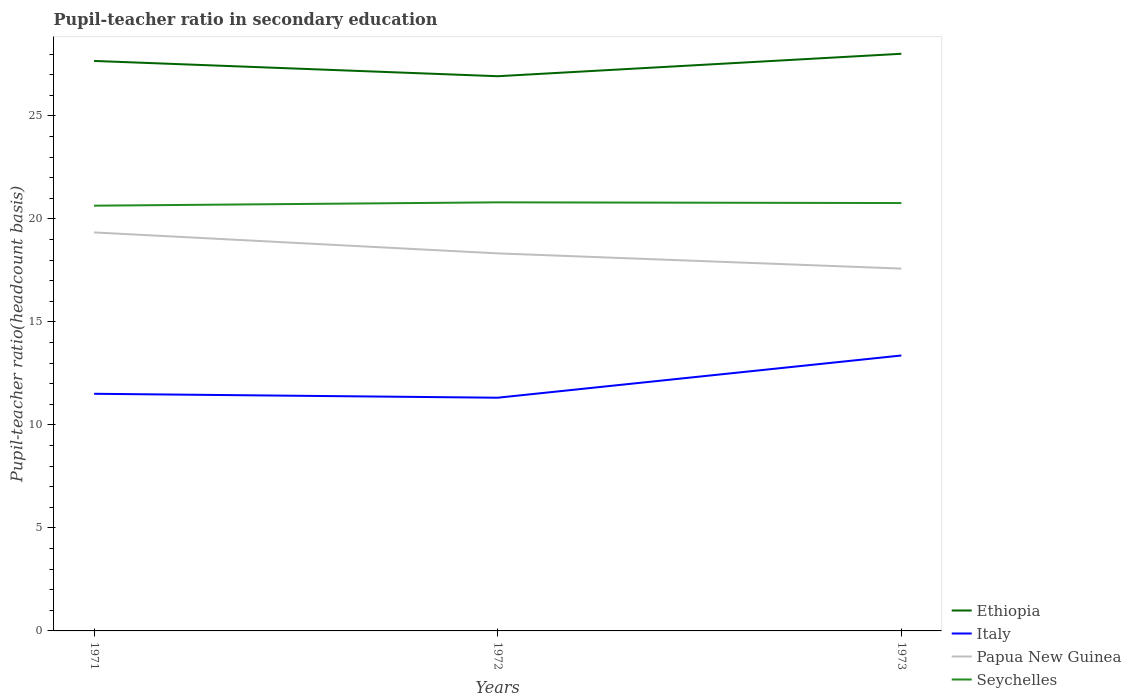Is the number of lines equal to the number of legend labels?
Keep it short and to the point. Yes. Across all years, what is the maximum pupil-teacher ratio in secondary education in Papua New Guinea?
Keep it short and to the point. 17.59. What is the total pupil-teacher ratio in secondary education in Ethiopia in the graph?
Offer a terse response. 0.74. What is the difference between the highest and the second highest pupil-teacher ratio in secondary education in Ethiopia?
Give a very brief answer. 1.09. What is the difference between the highest and the lowest pupil-teacher ratio in secondary education in Italy?
Provide a short and direct response. 1. How many years are there in the graph?
Your response must be concise. 3. How many legend labels are there?
Offer a terse response. 4. How are the legend labels stacked?
Provide a short and direct response. Vertical. What is the title of the graph?
Offer a very short reply. Pupil-teacher ratio in secondary education. Does "Least developed countries" appear as one of the legend labels in the graph?
Keep it short and to the point. No. What is the label or title of the X-axis?
Provide a succinct answer. Years. What is the label or title of the Y-axis?
Give a very brief answer. Pupil-teacher ratio(headcount basis). What is the Pupil-teacher ratio(headcount basis) in Ethiopia in 1971?
Make the answer very short. 27.67. What is the Pupil-teacher ratio(headcount basis) of Italy in 1971?
Make the answer very short. 11.51. What is the Pupil-teacher ratio(headcount basis) of Papua New Guinea in 1971?
Make the answer very short. 19.35. What is the Pupil-teacher ratio(headcount basis) in Seychelles in 1971?
Provide a succinct answer. 20.65. What is the Pupil-teacher ratio(headcount basis) in Ethiopia in 1972?
Provide a short and direct response. 26.93. What is the Pupil-teacher ratio(headcount basis) of Italy in 1972?
Keep it short and to the point. 11.32. What is the Pupil-teacher ratio(headcount basis) of Papua New Guinea in 1972?
Provide a succinct answer. 18.33. What is the Pupil-teacher ratio(headcount basis) in Seychelles in 1972?
Ensure brevity in your answer.  20.81. What is the Pupil-teacher ratio(headcount basis) in Ethiopia in 1973?
Provide a short and direct response. 28.02. What is the Pupil-teacher ratio(headcount basis) in Italy in 1973?
Offer a very short reply. 13.37. What is the Pupil-teacher ratio(headcount basis) of Papua New Guinea in 1973?
Provide a short and direct response. 17.59. What is the Pupil-teacher ratio(headcount basis) of Seychelles in 1973?
Make the answer very short. 20.77. Across all years, what is the maximum Pupil-teacher ratio(headcount basis) of Ethiopia?
Your answer should be very brief. 28.02. Across all years, what is the maximum Pupil-teacher ratio(headcount basis) in Italy?
Keep it short and to the point. 13.37. Across all years, what is the maximum Pupil-teacher ratio(headcount basis) of Papua New Guinea?
Offer a very short reply. 19.35. Across all years, what is the maximum Pupil-teacher ratio(headcount basis) in Seychelles?
Your answer should be compact. 20.81. Across all years, what is the minimum Pupil-teacher ratio(headcount basis) of Ethiopia?
Give a very brief answer. 26.93. Across all years, what is the minimum Pupil-teacher ratio(headcount basis) in Italy?
Make the answer very short. 11.32. Across all years, what is the minimum Pupil-teacher ratio(headcount basis) in Papua New Guinea?
Your answer should be very brief. 17.59. Across all years, what is the minimum Pupil-teacher ratio(headcount basis) of Seychelles?
Give a very brief answer. 20.65. What is the total Pupil-teacher ratio(headcount basis) of Ethiopia in the graph?
Provide a short and direct response. 82.62. What is the total Pupil-teacher ratio(headcount basis) of Italy in the graph?
Make the answer very short. 36.21. What is the total Pupil-teacher ratio(headcount basis) in Papua New Guinea in the graph?
Provide a succinct answer. 55.27. What is the total Pupil-teacher ratio(headcount basis) of Seychelles in the graph?
Provide a succinct answer. 62.23. What is the difference between the Pupil-teacher ratio(headcount basis) of Ethiopia in 1971 and that in 1972?
Offer a very short reply. 0.74. What is the difference between the Pupil-teacher ratio(headcount basis) in Italy in 1971 and that in 1972?
Provide a succinct answer. 0.19. What is the difference between the Pupil-teacher ratio(headcount basis) of Papua New Guinea in 1971 and that in 1972?
Keep it short and to the point. 1.02. What is the difference between the Pupil-teacher ratio(headcount basis) in Seychelles in 1971 and that in 1972?
Offer a terse response. -0.16. What is the difference between the Pupil-teacher ratio(headcount basis) of Ethiopia in 1971 and that in 1973?
Make the answer very short. -0.35. What is the difference between the Pupil-teacher ratio(headcount basis) in Italy in 1971 and that in 1973?
Your answer should be compact. -1.86. What is the difference between the Pupil-teacher ratio(headcount basis) in Papua New Guinea in 1971 and that in 1973?
Your answer should be very brief. 1.76. What is the difference between the Pupil-teacher ratio(headcount basis) in Seychelles in 1971 and that in 1973?
Offer a terse response. -0.13. What is the difference between the Pupil-teacher ratio(headcount basis) in Ethiopia in 1972 and that in 1973?
Your response must be concise. -1.09. What is the difference between the Pupil-teacher ratio(headcount basis) of Italy in 1972 and that in 1973?
Your response must be concise. -2.05. What is the difference between the Pupil-teacher ratio(headcount basis) of Papua New Guinea in 1972 and that in 1973?
Provide a short and direct response. 0.74. What is the difference between the Pupil-teacher ratio(headcount basis) of Seychelles in 1972 and that in 1973?
Make the answer very short. 0.03. What is the difference between the Pupil-teacher ratio(headcount basis) of Ethiopia in 1971 and the Pupil-teacher ratio(headcount basis) of Italy in 1972?
Ensure brevity in your answer.  16.35. What is the difference between the Pupil-teacher ratio(headcount basis) of Ethiopia in 1971 and the Pupil-teacher ratio(headcount basis) of Papua New Guinea in 1972?
Your answer should be very brief. 9.34. What is the difference between the Pupil-teacher ratio(headcount basis) in Ethiopia in 1971 and the Pupil-teacher ratio(headcount basis) in Seychelles in 1972?
Provide a succinct answer. 6.87. What is the difference between the Pupil-teacher ratio(headcount basis) in Italy in 1971 and the Pupil-teacher ratio(headcount basis) in Papua New Guinea in 1972?
Offer a terse response. -6.82. What is the difference between the Pupil-teacher ratio(headcount basis) in Italy in 1971 and the Pupil-teacher ratio(headcount basis) in Seychelles in 1972?
Ensure brevity in your answer.  -9.29. What is the difference between the Pupil-teacher ratio(headcount basis) in Papua New Guinea in 1971 and the Pupil-teacher ratio(headcount basis) in Seychelles in 1972?
Make the answer very short. -1.46. What is the difference between the Pupil-teacher ratio(headcount basis) of Ethiopia in 1971 and the Pupil-teacher ratio(headcount basis) of Italy in 1973?
Offer a terse response. 14.3. What is the difference between the Pupil-teacher ratio(headcount basis) of Ethiopia in 1971 and the Pupil-teacher ratio(headcount basis) of Papua New Guinea in 1973?
Give a very brief answer. 10.08. What is the difference between the Pupil-teacher ratio(headcount basis) in Ethiopia in 1971 and the Pupil-teacher ratio(headcount basis) in Seychelles in 1973?
Your response must be concise. 6.9. What is the difference between the Pupil-teacher ratio(headcount basis) of Italy in 1971 and the Pupil-teacher ratio(headcount basis) of Papua New Guinea in 1973?
Keep it short and to the point. -6.08. What is the difference between the Pupil-teacher ratio(headcount basis) in Italy in 1971 and the Pupil-teacher ratio(headcount basis) in Seychelles in 1973?
Give a very brief answer. -9.26. What is the difference between the Pupil-teacher ratio(headcount basis) of Papua New Guinea in 1971 and the Pupil-teacher ratio(headcount basis) of Seychelles in 1973?
Ensure brevity in your answer.  -1.43. What is the difference between the Pupil-teacher ratio(headcount basis) in Ethiopia in 1972 and the Pupil-teacher ratio(headcount basis) in Italy in 1973?
Give a very brief answer. 13.56. What is the difference between the Pupil-teacher ratio(headcount basis) in Ethiopia in 1972 and the Pupil-teacher ratio(headcount basis) in Papua New Guinea in 1973?
Provide a short and direct response. 9.34. What is the difference between the Pupil-teacher ratio(headcount basis) of Ethiopia in 1972 and the Pupil-teacher ratio(headcount basis) of Seychelles in 1973?
Ensure brevity in your answer.  6.16. What is the difference between the Pupil-teacher ratio(headcount basis) of Italy in 1972 and the Pupil-teacher ratio(headcount basis) of Papua New Guinea in 1973?
Give a very brief answer. -6.27. What is the difference between the Pupil-teacher ratio(headcount basis) of Italy in 1972 and the Pupil-teacher ratio(headcount basis) of Seychelles in 1973?
Make the answer very short. -9.45. What is the difference between the Pupil-teacher ratio(headcount basis) of Papua New Guinea in 1972 and the Pupil-teacher ratio(headcount basis) of Seychelles in 1973?
Make the answer very short. -2.44. What is the average Pupil-teacher ratio(headcount basis) of Ethiopia per year?
Keep it short and to the point. 27.54. What is the average Pupil-teacher ratio(headcount basis) of Italy per year?
Ensure brevity in your answer.  12.07. What is the average Pupil-teacher ratio(headcount basis) in Papua New Guinea per year?
Offer a very short reply. 18.42. What is the average Pupil-teacher ratio(headcount basis) in Seychelles per year?
Your response must be concise. 20.74. In the year 1971, what is the difference between the Pupil-teacher ratio(headcount basis) in Ethiopia and Pupil-teacher ratio(headcount basis) in Italy?
Offer a very short reply. 16.16. In the year 1971, what is the difference between the Pupil-teacher ratio(headcount basis) in Ethiopia and Pupil-teacher ratio(headcount basis) in Papua New Guinea?
Ensure brevity in your answer.  8.33. In the year 1971, what is the difference between the Pupil-teacher ratio(headcount basis) in Ethiopia and Pupil-teacher ratio(headcount basis) in Seychelles?
Make the answer very short. 7.03. In the year 1971, what is the difference between the Pupil-teacher ratio(headcount basis) in Italy and Pupil-teacher ratio(headcount basis) in Papua New Guinea?
Offer a very short reply. -7.83. In the year 1971, what is the difference between the Pupil-teacher ratio(headcount basis) of Italy and Pupil-teacher ratio(headcount basis) of Seychelles?
Offer a very short reply. -9.13. In the year 1971, what is the difference between the Pupil-teacher ratio(headcount basis) of Papua New Guinea and Pupil-teacher ratio(headcount basis) of Seychelles?
Give a very brief answer. -1.3. In the year 1972, what is the difference between the Pupil-teacher ratio(headcount basis) of Ethiopia and Pupil-teacher ratio(headcount basis) of Italy?
Give a very brief answer. 15.61. In the year 1972, what is the difference between the Pupil-teacher ratio(headcount basis) of Ethiopia and Pupil-teacher ratio(headcount basis) of Papua New Guinea?
Your answer should be very brief. 8.6. In the year 1972, what is the difference between the Pupil-teacher ratio(headcount basis) of Ethiopia and Pupil-teacher ratio(headcount basis) of Seychelles?
Offer a very short reply. 6.12. In the year 1972, what is the difference between the Pupil-teacher ratio(headcount basis) in Italy and Pupil-teacher ratio(headcount basis) in Papua New Guinea?
Offer a terse response. -7.01. In the year 1972, what is the difference between the Pupil-teacher ratio(headcount basis) of Italy and Pupil-teacher ratio(headcount basis) of Seychelles?
Provide a short and direct response. -9.49. In the year 1972, what is the difference between the Pupil-teacher ratio(headcount basis) in Papua New Guinea and Pupil-teacher ratio(headcount basis) in Seychelles?
Your response must be concise. -2.48. In the year 1973, what is the difference between the Pupil-teacher ratio(headcount basis) in Ethiopia and Pupil-teacher ratio(headcount basis) in Italy?
Your response must be concise. 14.65. In the year 1973, what is the difference between the Pupil-teacher ratio(headcount basis) in Ethiopia and Pupil-teacher ratio(headcount basis) in Papua New Guinea?
Offer a terse response. 10.43. In the year 1973, what is the difference between the Pupil-teacher ratio(headcount basis) in Ethiopia and Pupil-teacher ratio(headcount basis) in Seychelles?
Offer a very short reply. 7.25. In the year 1973, what is the difference between the Pupil-teacher ratio(headcount basis) in Italy and Pupil-teacher ratio(headcount basis) in Papua New Guinea?
Your response must be concise. -4.22. In the year 1973, what is the difference between the Pupil-teacher ratio(headcount basis) in Italy and Pupil-teacher ratio(headcount basis) in Seychelles?
Keep it short and to the point. -7.4. In the year 1973, what is the difference between the Pupil-teacher ratio(headcount basis) of Papua New Guinea and Pupil-teacher ratio(headcount basis) of Seychelles?
Provide a short and direct response. -3.18. What is the ratio of the Pupil-teacher ratio(headcount basis) of Ethiopia in 1971 to that in 1972?
Ensure brevity in your answer.  1.03. What is the ratio of the Pupil-teacher ratio(headcount basis) of Italy in 1971 to that in 1972?
Your response must be concise. 1.02. What is the ratio of the Pupil-teacher ratio(headcount basis) in Papua New Guinea in 1971 to that in 1972?
Ensure brevity in your answer.  1.06. What is the ratio of the Pupil-teacher ratio(headcount basis) in Seychelles in 1971 to that in 1972?
Give a very brief answer. 0.99. What is the ratio of the Pupil-teacher ratio(headcount basis) of Ethiopia in 1971 to that in 1973?
Your answer should be compact. 0.99. What is the ratio of the Pupil-teacher ratio(headcount basis) in Italy in 1971 to that in 1973?
Provide a short and direct response. 0.86. What is the ratio of the Pupil-teacher ratio(headcount basis) of Papua New Guinea in 1971 to that in 1973?
Your response must be concise. 1.1. What is the ratio of the Pupil-teacher ratio(headcount basis) of Seychelles in 1971 to that in 1973?
Keep it short and to the point. 0.99. What is the ratio of the Pupil-teacher ratio(headcount basis) of Ethiopia in 1972 to that in 1973?
Give a very brief answer. 0.96. What is the ratio of the Pupil-teacher ratio(headcount basis) in Italy in 1972 to that in 1973?
Offer a very short reply. 0.85. What is the ratio of the Pupil-teacher ratio(headcount basis) in Papua New Guinea in 1972 to that in 1973?
Your answer should be very brief. 1.04. What is the ratio of the Pupil-teacher ratio(headcount basis) of Seychelles in 1972 to that in 1973?
Your answer should be very brief. 1. What is the difference between the highest and the second highest Pupil-teacher ratio(headcount basis) of Ethiopia?
Give a very brief answer. 0.35. What is the difference between the highest and the second highest Pupil-teacher ratio(headcount basis) in Italy?
Give a very brief answer. 1.86. What is the difference between the highest and the second highest Pupil-teacher ratio(headcount basis) in Papua New Guinea?
Your response must be concise. 1.02. What is the difference between the highest and the second highest Pupil-teacher ratio(headcount basis) of Seychelles?
Provide a succinct answer. 0.03. What is the difference between the highest and the lowest Pupil-teacher ratio(headcount basis) of Ethiopia?
Your answer should be very brief. 1.09. What is the difference between the highest and the lowest Pupil-teacher ratio(headcount basis) in Italy?
Your response must be concise. 2.05. What is the difference between the highest and the lowest Pupil-teacher ratio(headcount basis) in Papua New Guinea?
Provide a short and direct response. 1.76. What is the difference between the highest and the lowest Pupil-teacher ratio(headcount basis) in Seychelles?
Offer a terse response. 0.16. 